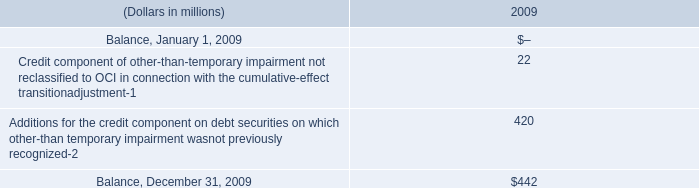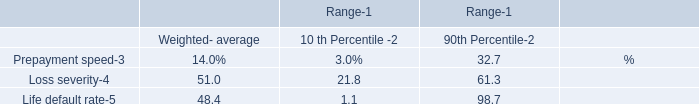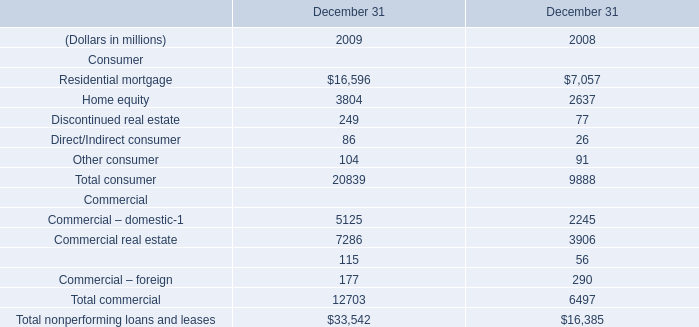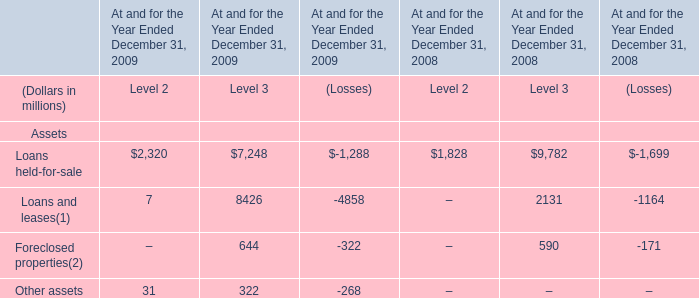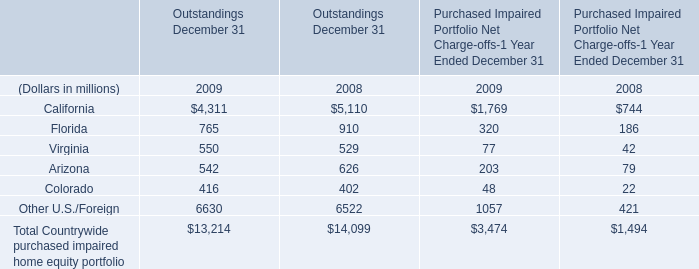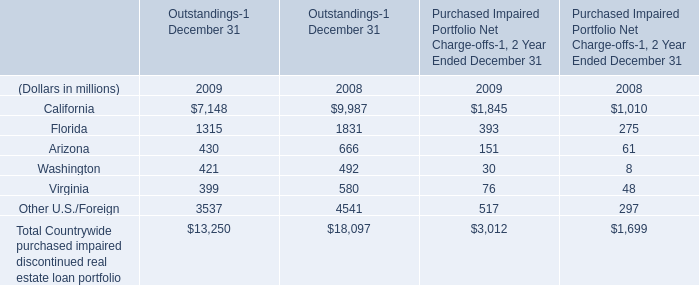What will Outstandings of Virginia be like in 2010 if it continues to grow at the same rate as it did in 2009? (in million) 
Computations: (550 + ((550 * (550 - 529)) / 529))
Answer: 571.83365. 